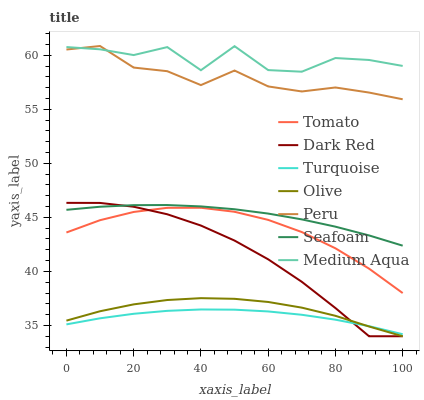Does Turquoise have the minimum area under the curve?
Answer yes or no. Yes. Does Medium Aqua have the maximum area under the curve?
Answer yes or no. Yes. Does Dark Red have the minimum area under the curve?
Answer yes or no. No. Does Dark Red have the maximum area under the curve?
Answer yes or no. No. Is Seafoam the smoothest?
Answer yes or no. Yes. Is Medium Aqua the roughest?
Answer yes or no. Yes. Is Turquoise the smoothest?
Answer yes or no. No. Is Turquoise the roughest?
Answer yes or no. No. Does Dark Red have the lowest value?
Answer yes or no. Yes. Does Turquoise have the lowest value?
Answer yes or no. No. Does Peru have the highest value?
Answer yes or no. Yes. Does Dark Red have the highest value?
Answer yes or no. No. Is Seafoam less than Medium Aqua?
Answer yes or no. Yes. Is Tomato greater than Olive?
Answer yes or no. Yes. Does Seafoam intersect Dark Red?
Answer yes or no. Yes. Is Seafoam less than Dark Red?
Answer yes or no. No. Is Seafoam greater than Dark Red?
Answer yes or no. No. Does Seafoam intersect Medium Aqua?
Answer yes or no. No. 